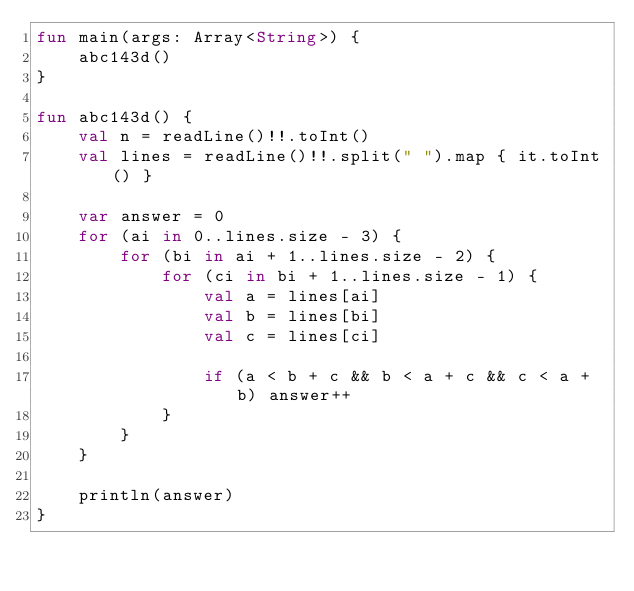Convert code to text. <code><loc_0><loc_0><loc_500><loc_500><_Kotlin_>fun main(args: Array<String>) {
    abc143d()
}

fun abc143d() {
    val n = readLine()!!.toInt()
    val lines = readLine()!!.split(" ").map { it.toInt() }

    var answer = 0
    for (ai in 0..lines.size - 3) {
        for (bi in ai + 1..lines.size - 2) {
            for (ci in bi + 1..lines.size - 1) {
                val a = lines[ai]
                val b = lines[bi]
                val c = lines[ci]

                if (a < b + c && b < a + c && c < a + b) answer++
            }
        }
    }

    println(answer)
}
</code> 